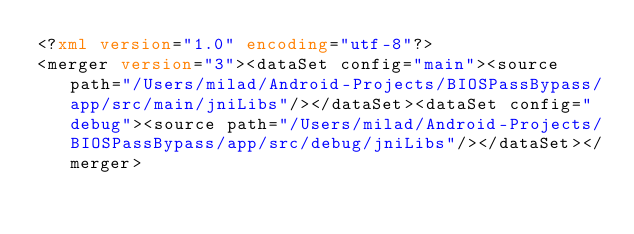<code> <loc_0><loc_0><loc_500><loc_500><_XML_><?xml version="1.0" encoding="utf-8"?>
<merger version="3"><dataSet config="main"><source path="/Users/milad/Android-Projects/BIOSPassBypass/app/src/main/jniLibs"/></dataSet><dataSet config="debug"><source path="/Users/milad/Android-Projects/BIOSPassBypass/app/src/debug/jniLibs"/></dataSet></merger></code> 